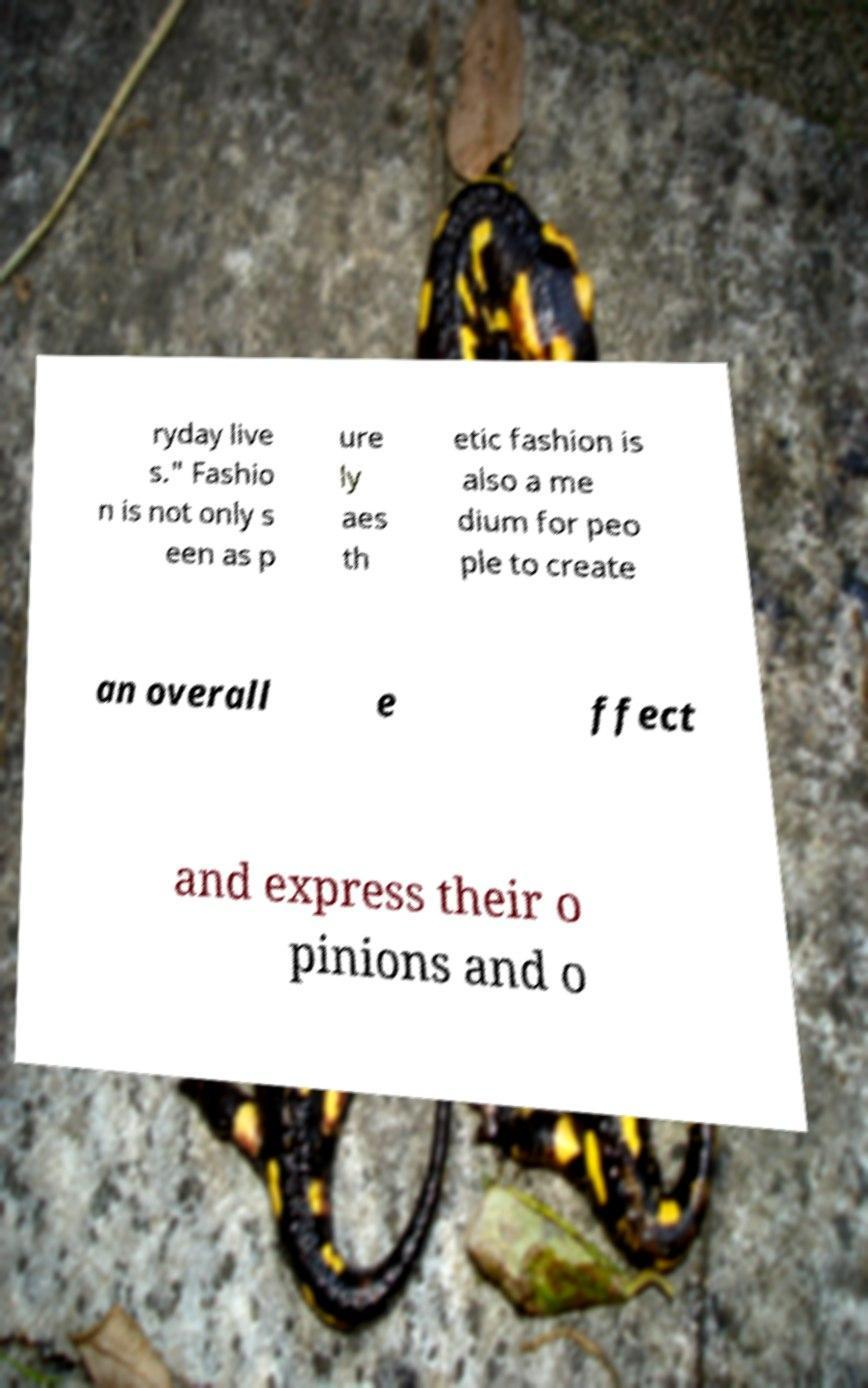There's text embedded in this image that I need extracted. Can you transcribe it verbatim? ryday live s." Fashio n is not only s een as p ure ly aes th etic fashion is also a me dium for peo ple to create an overall e ffect and express their o pinions and o 